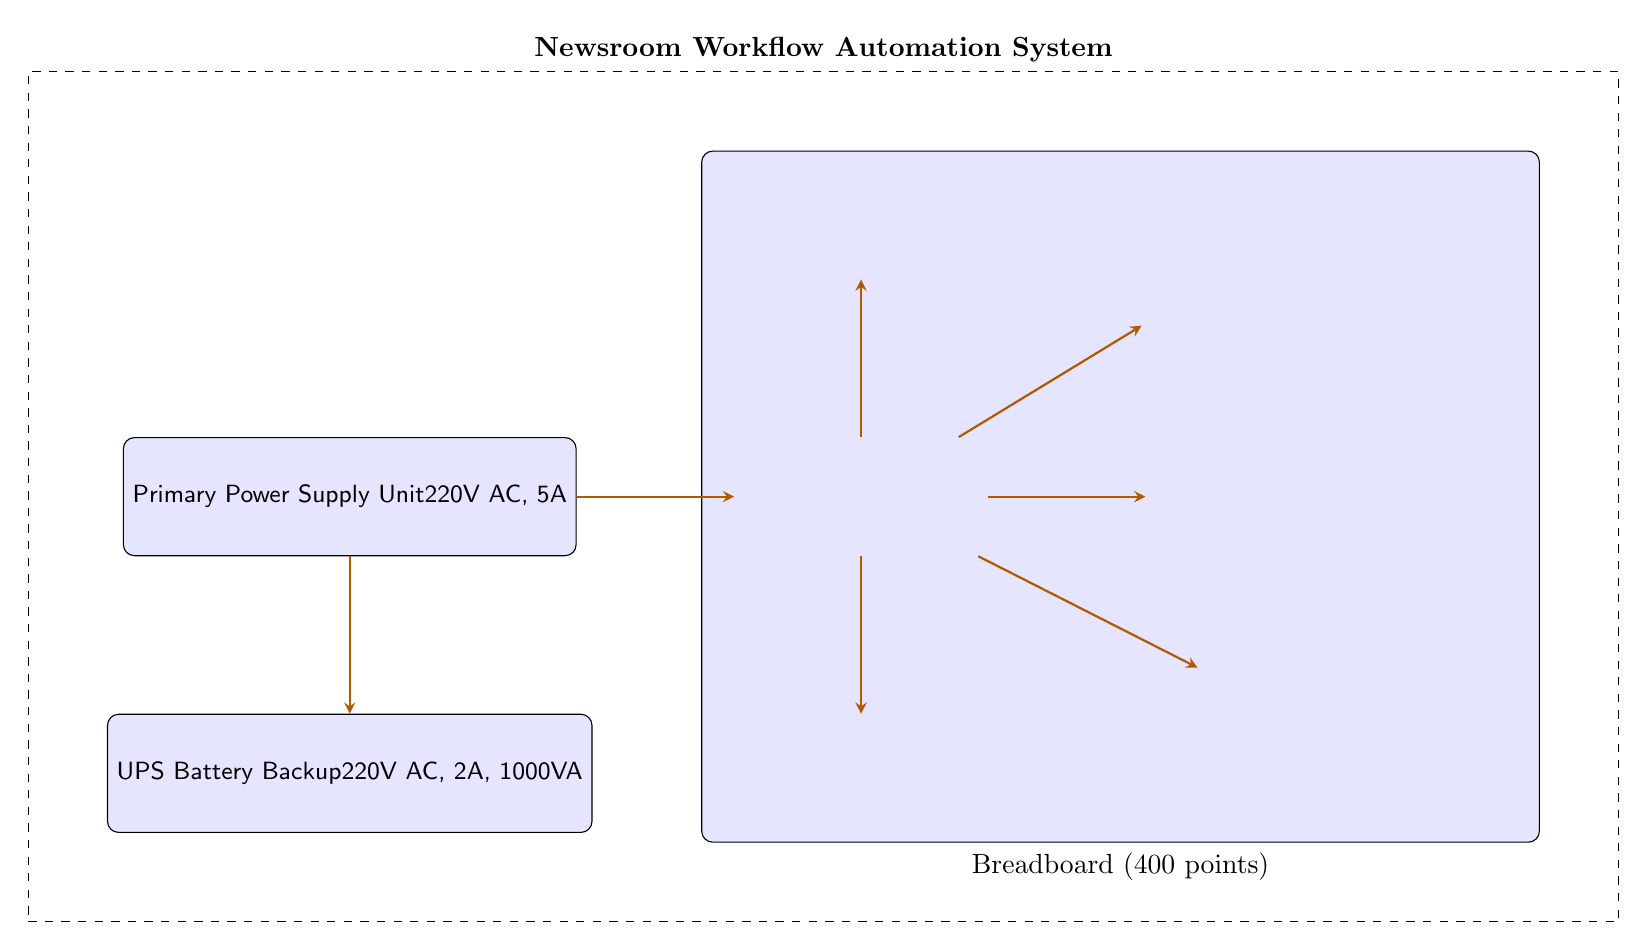What is the voltage rating of the Primary Power Supply Unit? The Primary Power Supply Unit is labeled with a voltage rating of 220V AC, which is directly visible in the diagram.
Answer: 220V AC How many components are connected to the Raspberry Pi 4? The Raspberry Pi 4 has connections to six components: the RFID Reader, Motorized Blinds, LCD Display Panel, WiFi Module, and SD Card. This can be counted from the lines connecting to the Raspberry Pi in the diagram.
Answer: 6 What is the power requirement of the UPS Battery Backup? The UPS Battery Backup is specified with a power capacity of 1000VA, which is indicated in its label within the diagram.
Answer: 1000VA Which component requires 12V? Both the Motorized Blinds and the LCD Display Panel require 12V, which can be identified by checking their individual labels in the diagram.
Answer: Motorized Blinds and LCD Display Panel What is the total current required by components connected to the Raspberry Pi? The Raspberry Pi is connected to WLAN (500mA), RFID (500mA), Motorized Blinds (1A), and LCD Display Panel (1A). Summing these gives a total current requirement of 3A + 0.5A + 1A + 1A = 5A
Answer: 5A What type of system does the dashed box enclose? The dashed box encompasses the entire circuit labeled as the "Newsroom Workflow Automation System," which contains the main components and their connections that contribute to the workflow automation.
Answer: Newsroom Workflow Automation System What is the required voltage for the LCD Display Panel? The LCD Display Panel requires 12V as indicated in its specification found in the diagram.
Answer: 12V Which two components operate at 5V? The Raspberry Pi 4 and the RFID Reader both operate at a voltage of 5V, as noted in the diagram.
Answer: Raspberry Pi 4 and RFID Reader 